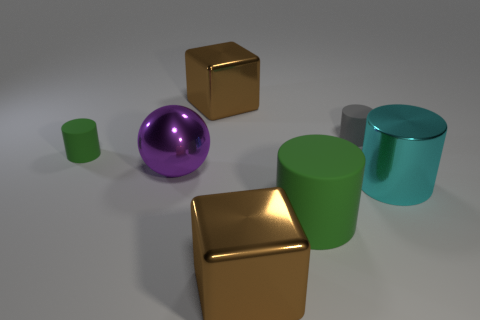How many other things are the same material as the purple sphere?
Your response must be concise. 3. What shape is the green thing that is in front of the rubber thing that is left of the large rubber thing?
Give a very brief answer. Cylinder. How many objects are either small green balls or shiny things to the right of the purple thing?
Provide a succinct answer. 3. What number of other things are the same color as the sphere?
Provide a short and direct response. 0. How many gray things are either rubber cylinders or small rubber cylinders?
Your answer should be compact. 1. Is there a shiny thing that is to the right of the green matte object that is in front of the green cylinder left of the ball?
Offer a very short reply. Yes. Are there any other things that have the same size as the gray matte cylinder?
Ensure brevity in your answer.  Yes. Is the metal ball the same color as the big rubber thing?
Provide a short and direct response. No. There is a large metal cube that is behind the large cube in front of the metal cylinder; what is its color?
Offer a very short reply. Brown. How many big things are either green matte cylinders or cyan objects?
Keep it short and to the point. 2. 